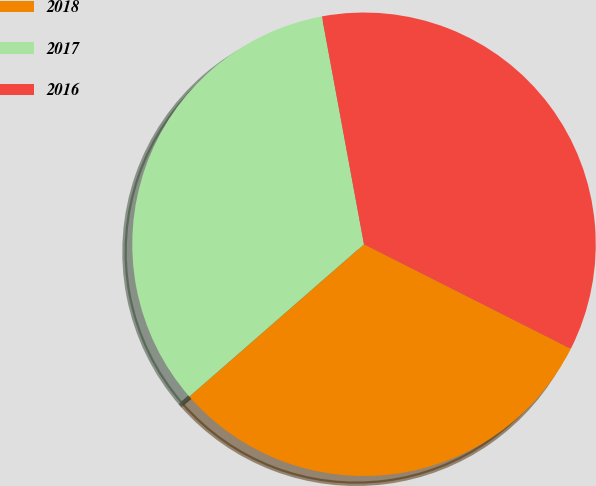<chart> <loc_0><loc_0><loc_500><loc_500><pie_chart><fcel>2018<fcel>2017<fcel>2016<nl><fcel>31.14%<fcel>33.51%<fcel>35.35%<nl></chart> 